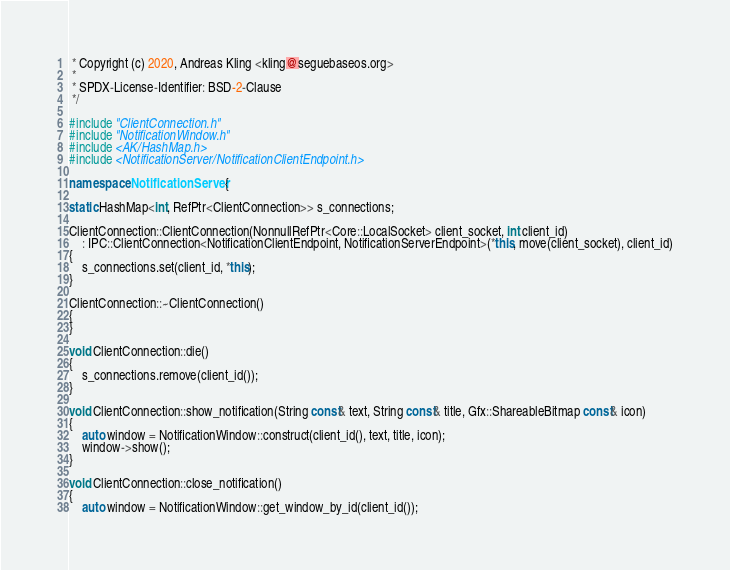Convert code to text. <code><loc_0><loc_0><loc_500><loc_500><_C++_> * Copyright (c) 2020, Andreas Kling <kling@seguebaseos.org>
 *
 * SPDX-License-Identifier: BSD-2-Clause
 */

#include "ClientConnection.h"
#include "NotificationWindow.h"
#include <AK/HashMap.h>
#include <NotificationServer/NotificationClientEndpoint.h>

namespace NotificationServer {

static HashMap<int, RefPtr<ClientConnection>> s_connections;

ClientConnection::ClientConnection(NonnullRefPtr<Core::LocalSocket> client_socket, int client_id)
    : IPC::ClientConnection<NotificationClientEndpoint, NotificationServerEndpoint>(*this, move(client_socket), client_id)
{
    s_connections.set(client_id, *this);
}

ClientConnection::~ClientConnection()
{
}

void ClientConnection::die()
{
    s_connections.remove(client_id());
}

void ClientConnection::show_notification(String const& text, String const& title, Gfx::ShareableBitmap const& icon)
{
    auto window = NotificationWindow::construct(client_id(), text, title, icon);
    window->show();
}

void ClientConnection::close_notification()
{
    auto window = NotificationWindow::get_window_by_id(client_id());</code> 